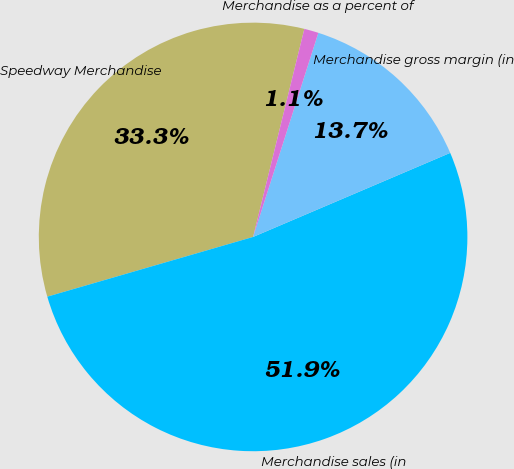Convert chart to OTSL. <chart><loc_0><loc_0><loc_500><loc_500><pie_chart><fcel>Speedway Merchandise<fcel>Merchandise sales (in<fcel>Merchandise gross margin (in<fcel>Merchandise as a percent of<nl><fcel>33.34%<fcel>51.92%<fcel>13.66%<fcel>1.08%<nl></chart> 